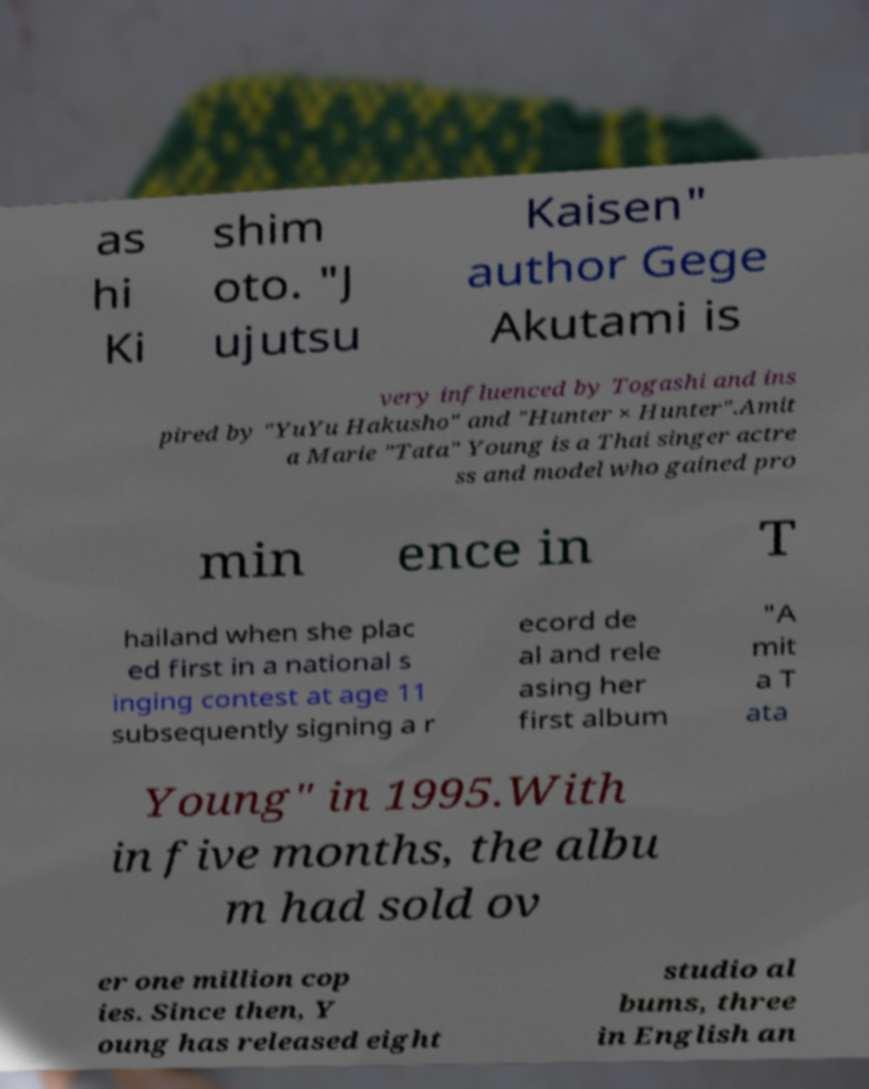For documentation purposes, I need the text within this image transcribed. Could you provide that? as hi Ki shim oto. "J ujutsu Kaisen" author Gege Akutami is very influenced by Togashi and ins pired by "YuYu Hakusho" and "Hunter × Hunter".Amit a Marie "Tata" Young is a Thai singer actre ss and model who gained pro min ence in T hailand when she plac ed first in a national s inging contest at age 11 subsequently signing a r ecord de al and rele asing her first album "A mit a T ata Young" in 1995.With in five months, the albu m had sold ov er one million cop ies. Since then, Y oung has released eight studio al bums, three in English an 